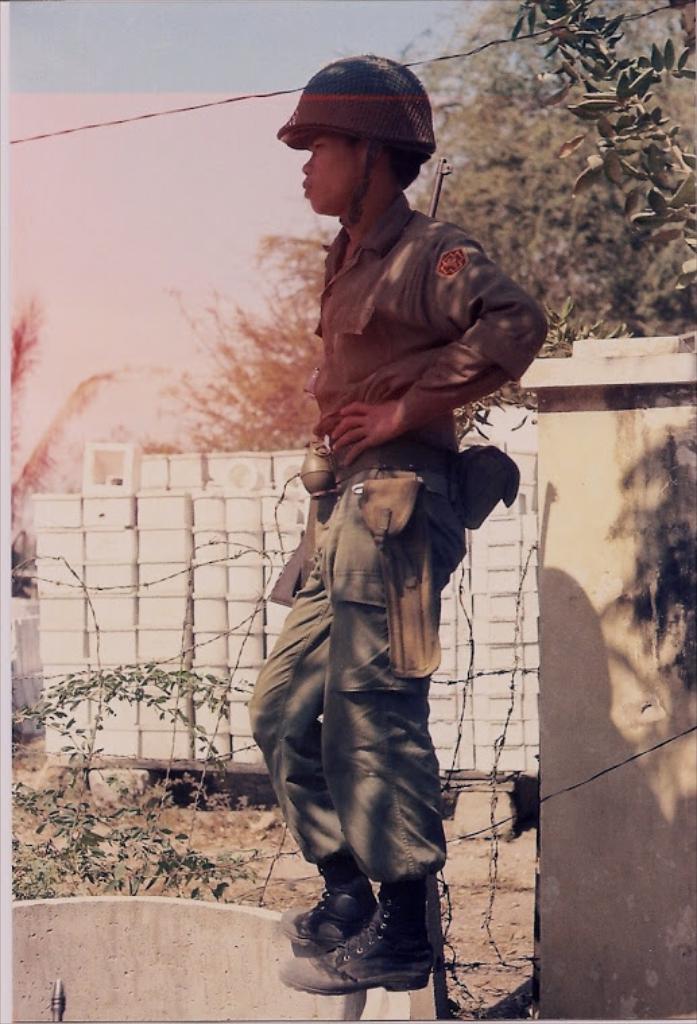Could you give a brief overview of what you see in this image? As we can see in the image there is a man standing, wall, plant and trees. On the top there is sky. 